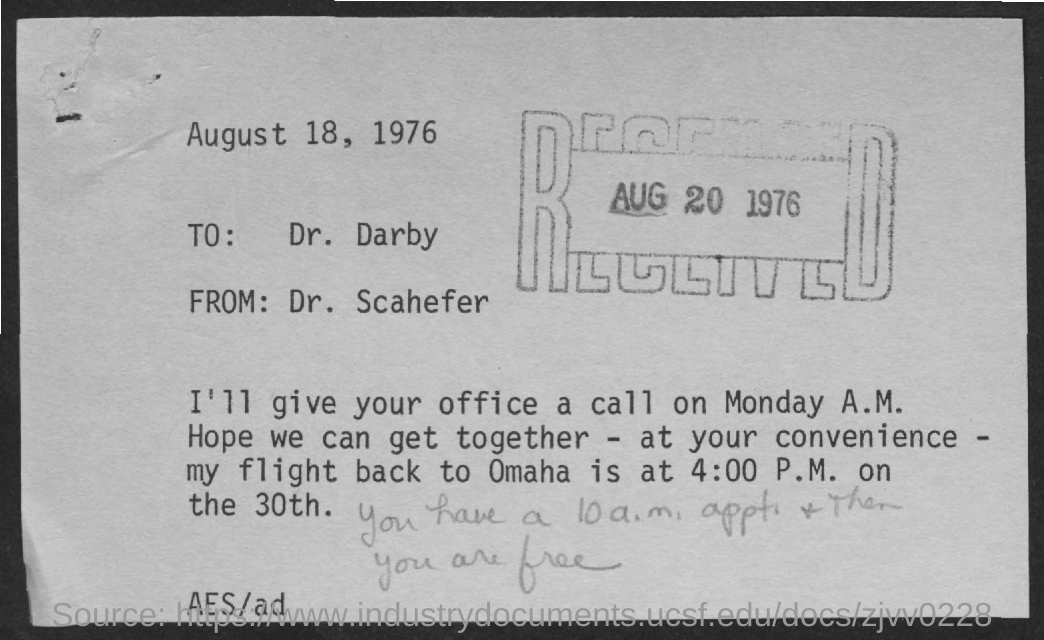Mention a couple of crucial points in this snapshot. The from address of the letter is Dr. Scahefer. The time of flight back to Omaha is 4:00 P.M. The office call is scheduled for Monday morning. The letter was written on August 18, 1976. The date on the stamp is August 20, 1976. 